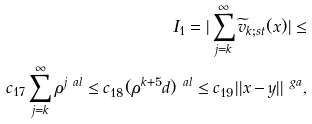Convert formula to latex. <formula><loc_0><loc_0><loc_500><loc_500>I _ { 1 } = | \sum _ { j = k } ^ { \infty } \widetilde { v } _ { k ; s t } ( x ) | \leq \\ c _ { 1 7 } \sum _ { j = k } ^ { \infty } \rho ^ { j \ a l } \leq c _ { 1 8 } ( \rho ^ { k + 5 } d ) ^ { \ a l } \leq c _ { 1 9 } | | x - y | | ^ { \ g a } ,</formula> 